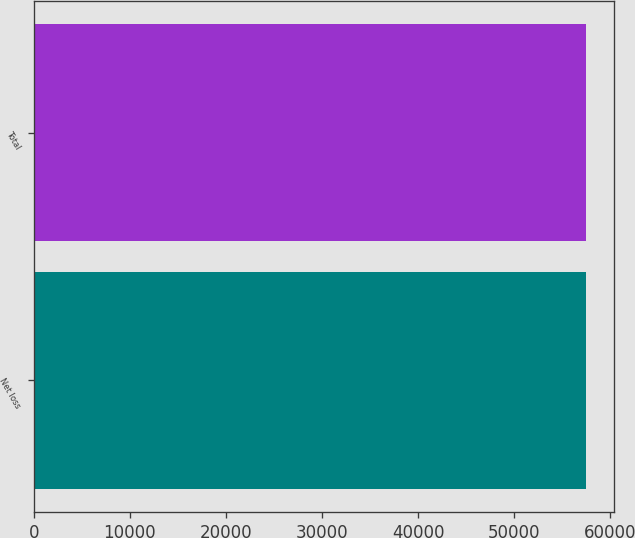Convert chart to OTSL. <chart><loc_0><loc_0><loc_500><loc_500><bar_chart><fcel>Net loss<fcel>Total<nl><fcel>57446<fcel>57446.1<nl></chart> 